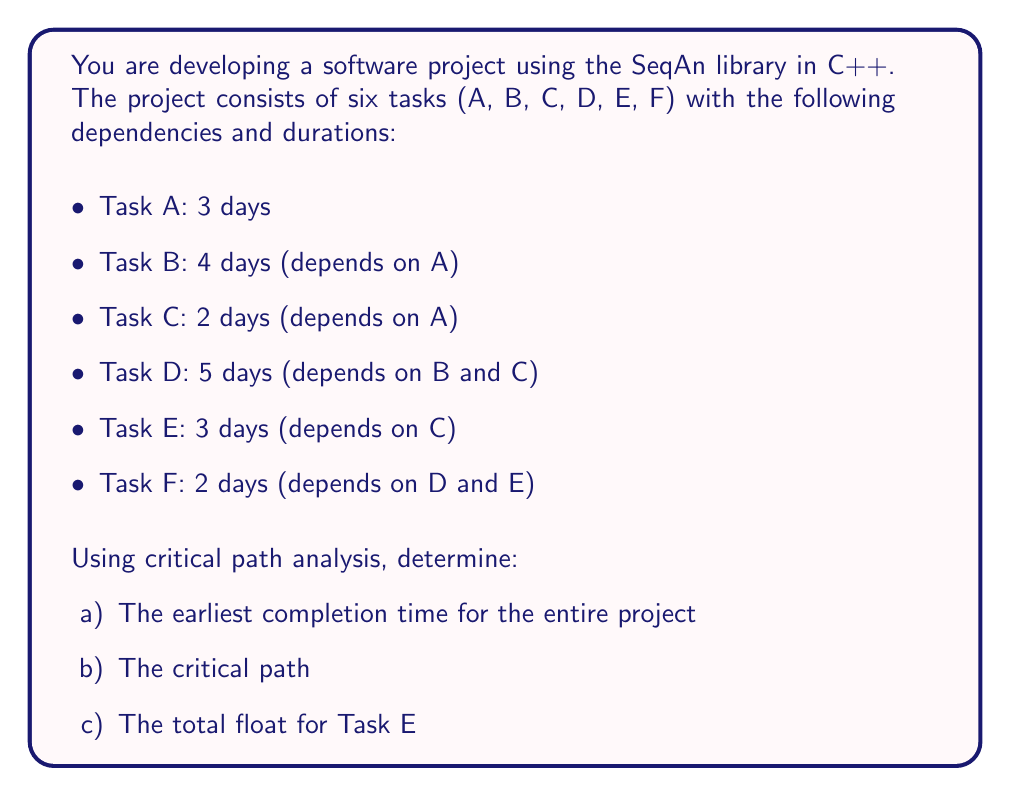Teach me how to tackle this problem. To solve this problem, we'll use the Critical Path Method (CPM) and construct a network diagram.

1. Create a network diagram:
[asy]
unitsize(1cm);

void drawNode(pair p, string label) {
  fill(p, circle(0.4));
  label(label, p, white);
}

void drawArrow(pair start, pair end, string label="") {
  draw(start--end, arrow=Arrow(TeXHead));
  label(label, midpoint(start--end), N);
}

drawNode((0,0), "Start");
drawNode((3,1), "A");
drawNode((7,2), "B");
drawNode((7,0), "C");
drawNode((11,1), "D");
drawNode((11,-1), "E");
drawNode((15,0), "F");
drawNode((18,0), "End");

drawArrow((0.4,0), (2.6,1), "3");
drawArrow((3.4,1), (6.6,2), "4");
drawArrow((3.4,0.9), (6.6,0.1), "2");
drawArrow((7.4,1.9), (10.6,1.1), "5");
drawArrow((7.4,-0.1), (10.6,-0.9), "3");
drawArrow((7.4,0), (10.6,0.9), "5");
drawArrow((11.4,0.9), (14.6,0.1), "2");
drawArrow((11.4,-0.9), (14.6,-0.1), "2");
drawArrow((15.4,0), (17.6,0), "0");
[/asy]

2. Calculate earliest start (ES) and earliest finish (EF) times:
   - A: ES = 0, EF = 3
   - B: ES = 3, EF = 7
   - C: ES = 3, EF = 5
   - D: ES = max(7, 5) = 7, EF = 12
   - E: ES = 5, EF = 8
   - F: ES = max(12, 8) = 12, EF = 14

3. Calculate latest start (LS) and latest finish (LF) times:
   - F: LF = 14, LS = 12
   - D: LF = 12, LS = 7
   - E: LF = 12, LS = 9
   - B: LF = 7, LS = 3
   - C: LF = 7, LS = 5
   - A: LF = 3, LS = 0

4. Calculate float for each task:
   Float = LS - ES or LF - EF
   - A: 0 - 0 = 0
   - B: 3 - 3 = 0
   - C: 5 - 3 = 2
   - D: 7 - 7 = 0
   - E: 9 - 5 = 4
   - F: 12 - 12 = 0

5. Identify the critical path:
   The critical path consists of tasks with zero float:
   A → B → D → F

Now we can answer the questions:

a) The earliest completion time for the entire project is the EF of the last task, which is 14 days.

b) The critical path is A → B → D → F.

c) The total float for Task E is 4 days.
Answer: a) 14 days
b) A → B → D → F
c) 4 days 